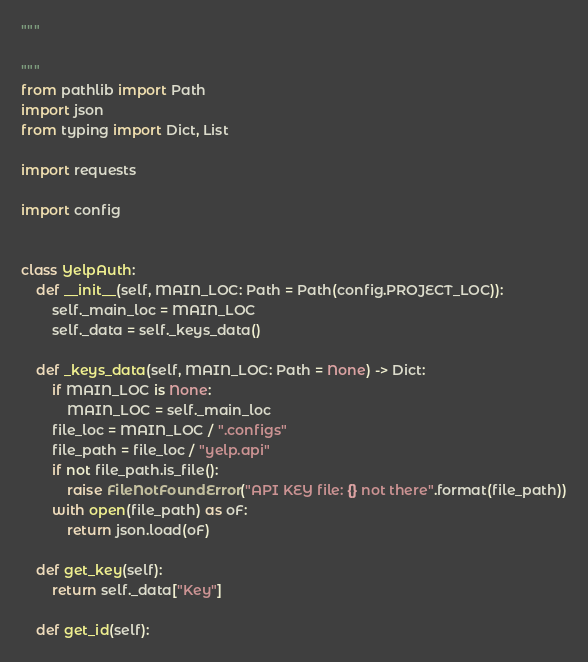Convert code to text. <code><loc_0><loc_0><loc_500><loc_500><_Python_>"""

"""
from pathlib import Path
import json
from typing import Dict, List

import requests

import config


class YelpAuth:
    def __init__(self, MAIN_LOC: Path = Path(config.PROJECT_LOC)):
        self._main_loc = MAIN_LOC
        self._data = self._keys_data()

    def _keys_data(self, MAIN_LOC: Path = None) -> Dict:
        if MAIN_LOC is None:
            MAIN_LOC = self._main_loc
        file_loc = MAIN_LOC / ".configs"
        file_path = file_loc / "yelp.api"
        if not file_path.is_file():
            raise FileNotFoundError("API KEY file: {} not there".format(file_path))
        with open(file_path) as oF:
            return json.load(oF)

    def get_key(self):
        return self._data["Key"]

    def get_id(self):</code> 